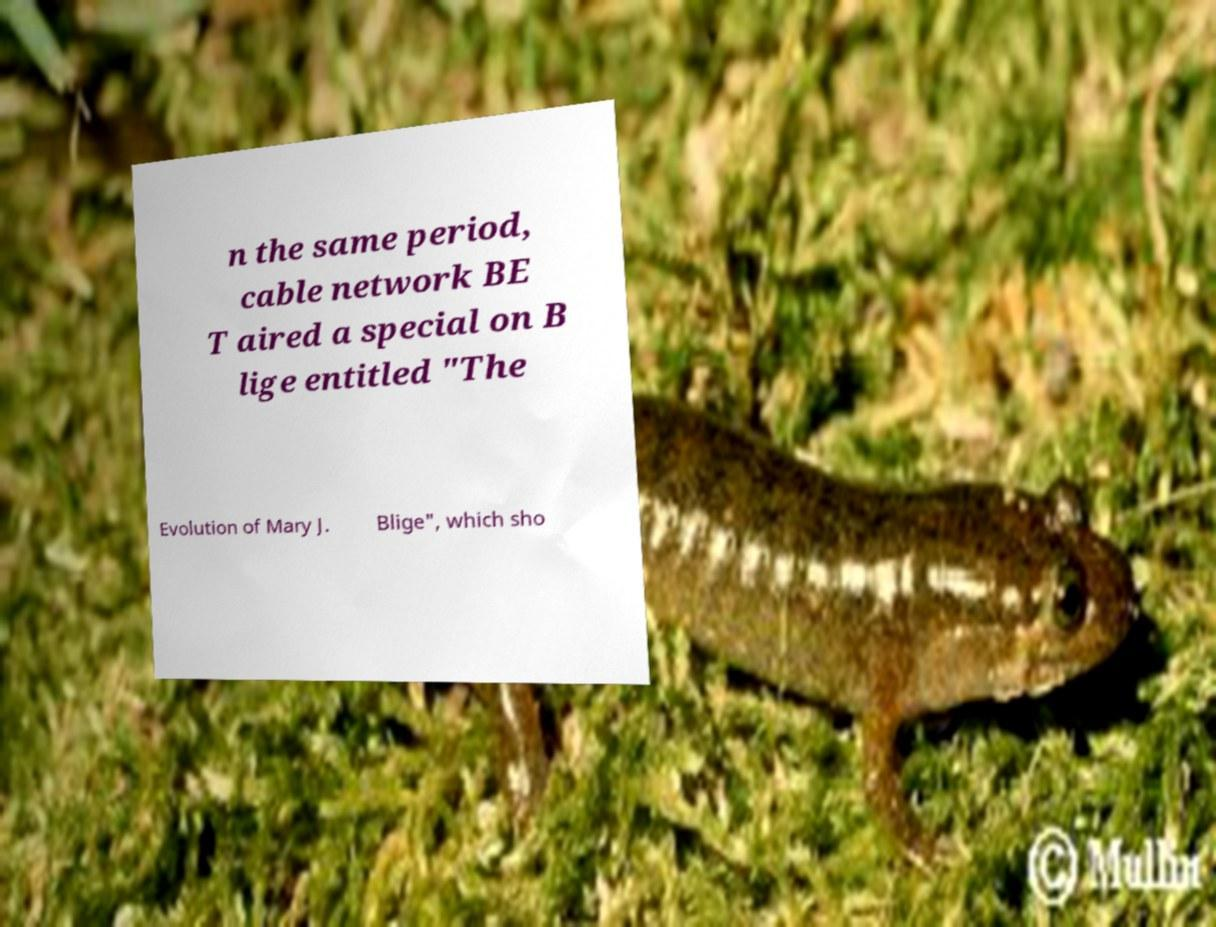Please identify and transcribe the text found in this image. n the same period, cable network BE T aired a special on B lige entitled "The Evolution of Mary J. Blige", which sho 